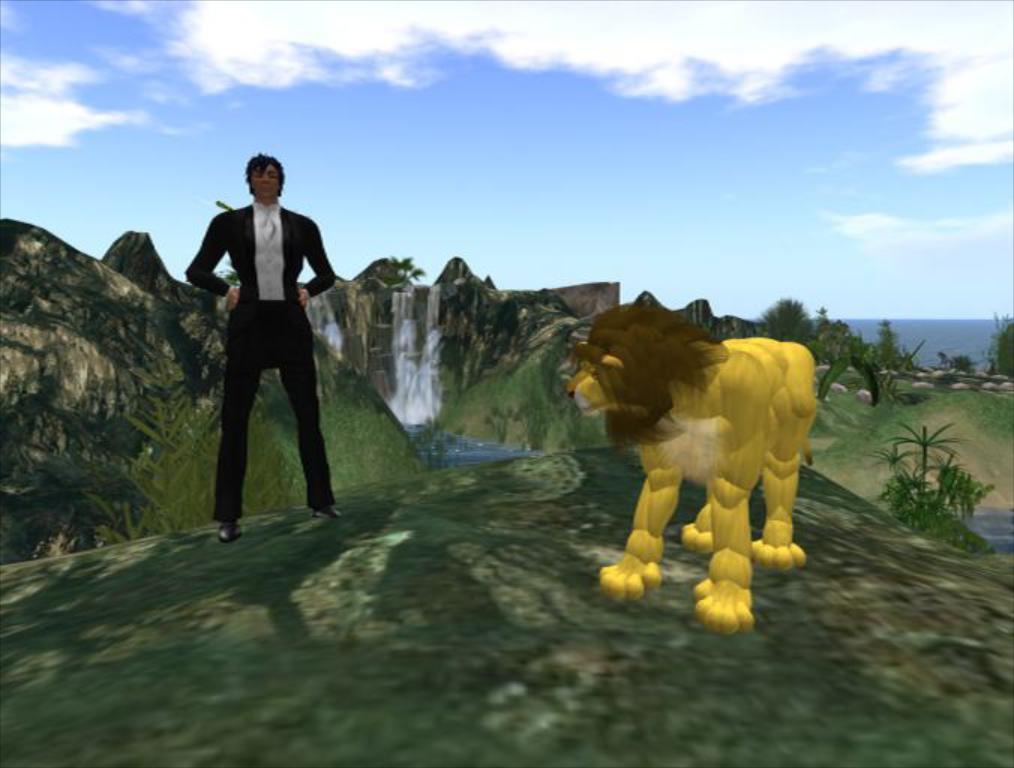Could you give a brief overview of what you see in this image? This is an animation picture. In this image there is a man and there is a lion standing in the foreground. At the back there is a mountain and there are trees and there is a waterfall. On the right side of the image there is water and there are stones. At the top there is sky and there are clouds. 